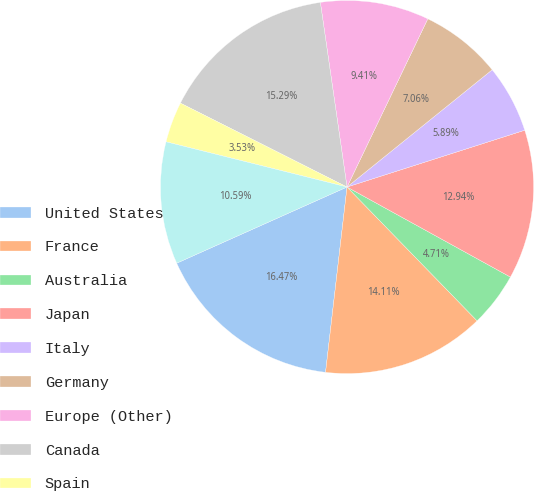Convert chart. <chart><loc_0><loc_0><loc_500><loc_500><pie_chart><fcel>United States<fcel>France<fcel>Australia<fcel>Japan<fcel>Italy<fcel>Germany<fcel>Europe (Other)<fcel>Canada<fcel>Spain<fcel>Mexico<nl><fcel>16.47%<fcel>14.11%<fcel>4.71%<fcel>12.94%<fcel>5.89%<fcel>7.06%<fcel>9.41%<fcel>15.29%<fcel>3.53%<fcel>10.59%<nl></chart> 